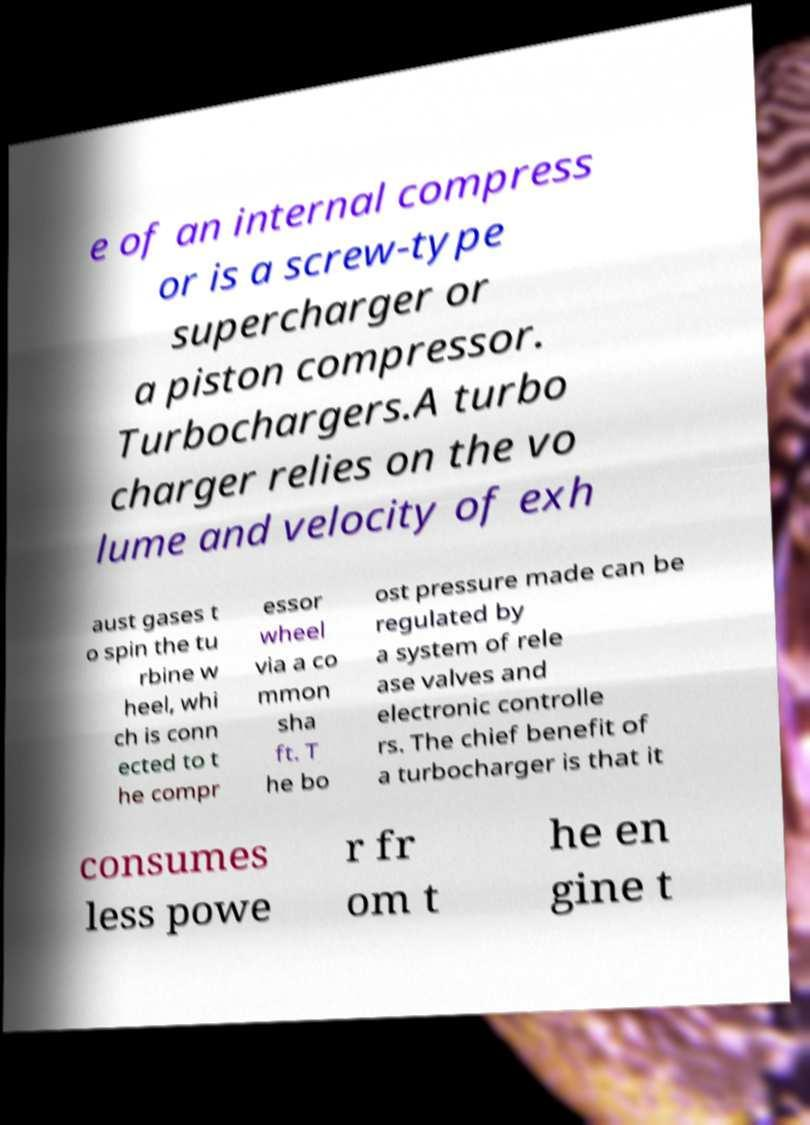What messages or text are displayed in this image? I need them in a readable, typed format. e of an internal compress or is a screw-type supercharger or a piston compressor. Turbochargers.A turbo charger relies on the vo lume and velocity of exh aust gases t o spin the tu rbine w heel, whi ch is conn ected to t he compr essor wheel via a co mmon sha ft. T he bo ost pressure made can be regulated by a system of rele ase valves and electronic controlle rs. The chief benefit of a turbocharger is that it consumes less powe r fr om t he en gine t 